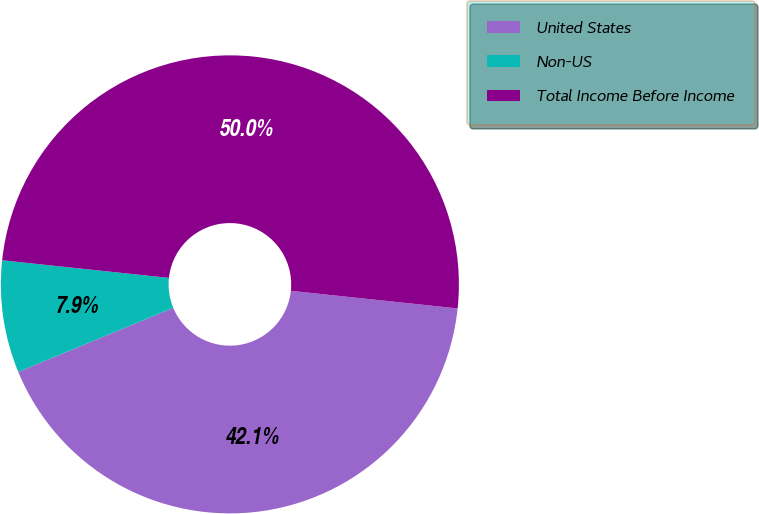Convert chart to OTSL. <chart><loc_0><loc_0><loc_500><loc_500><pie_chart><fcel>United States<fcel>Non-US<fcel>Total Income Before Income<nl><fcel>42.08%<fcel>7.92%<fcel>50.0%<nl></chart> 